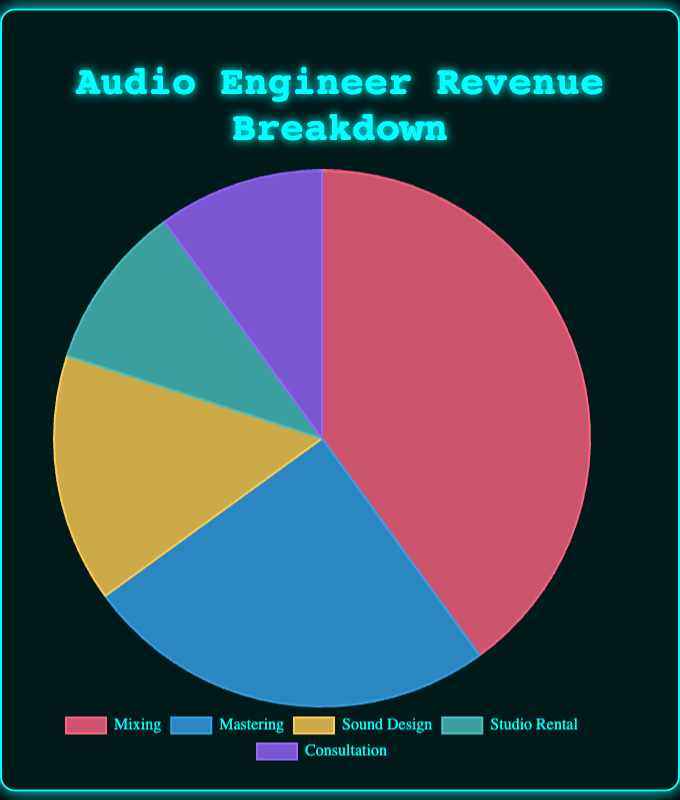Which revenue source has the largest percentage? The pie chart shows that the segment labeled "Mixing" is the largest. The legend indicates that "Mixing" accounts for 40% of the revenue.
Answer: Mixing What is the combined percentage of Studio Rental and Consultation? According to the pie chart, "Studio Rental" and "Consultation" each contribute 10%. Adding these percentages together gives 10% + 10% = 20%.
Answer: 20% Which two revenue sources combined are equal to the percentage of Mixing? "Mixing" accounts for 40%. Both "Sound Design" (15%) and "Mastering" (25%) together total 15% + 25% = 40%.
Answer: Sound Design and Mastering By how much does the percentage of Mastering exceed that of Sound Design? "Mastering" is 25% and "Sound Design" is 15%. The difference between them is 25% - 15% = 10%.
Answer: 10% What color represents the Sound Design segment? The pie chart has visual cues indicating that "Sound Design" is represented by a yellow segment.
Answer: Yellow What is the percentage difference between the smallest and largest revenue sources? The largest is "Mixing" at 40%, and the smallest are "Studio Rental" and "Consultation", each at 10%. The difference is 40% - 10% = 30%.
Answer: 30% Are any of the revenue sources equal in percentage? According to the pie chart, both "Studio Rental" and "Consultation" have the same percentage of 10%.
Answer: Studio Rental and Consultation What is the total percentage of revenue not attributed to Mixing? "Mixing" accounts for 40% of the revenue. The remaining is 100% - 40% = 60%.
Answer: 60% How does the percentage of Sound Design compared to Consultation? Both "Sound Design" (15%) is greater than "Consultation" (10%). 15% is greater than 10%.
Answer: Greater 